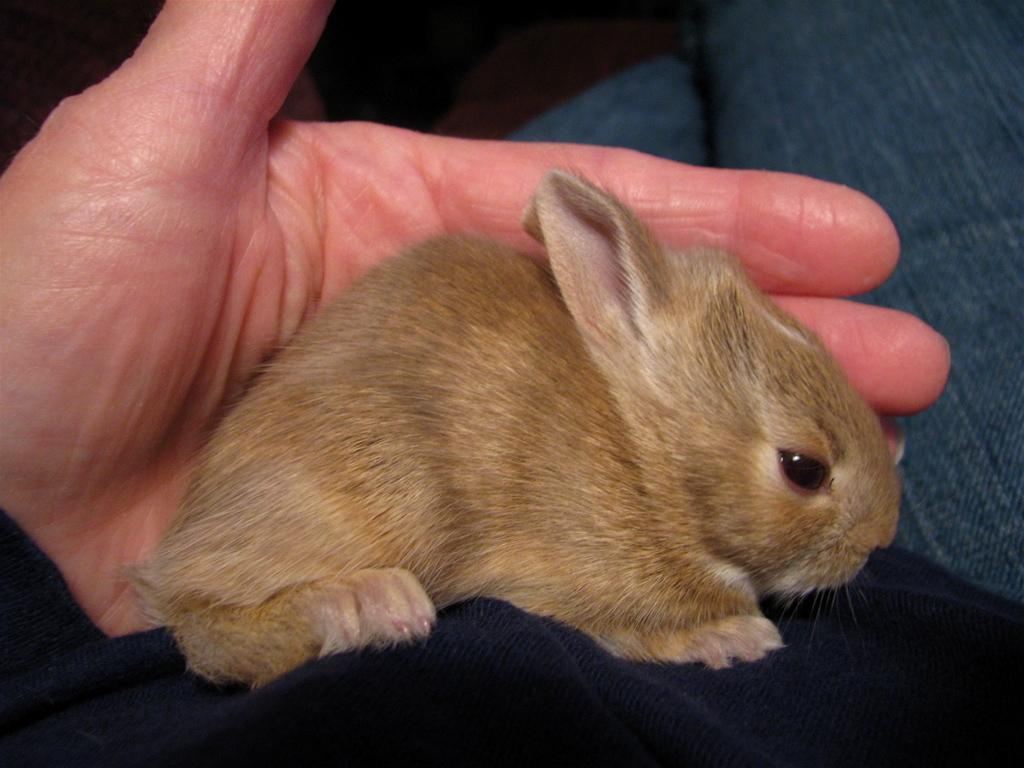What type of animal is present in the image? There is a rat in the image. Where is the rat located in the image? The rat is on the body of a person. What type of pollution is depicted in the image? There is no depiction of pollution in the image; it features a rat on the body of a person. What type of beetle can be seen in the image? There is no beetle present in the image; it features a rat on the body of a person. 